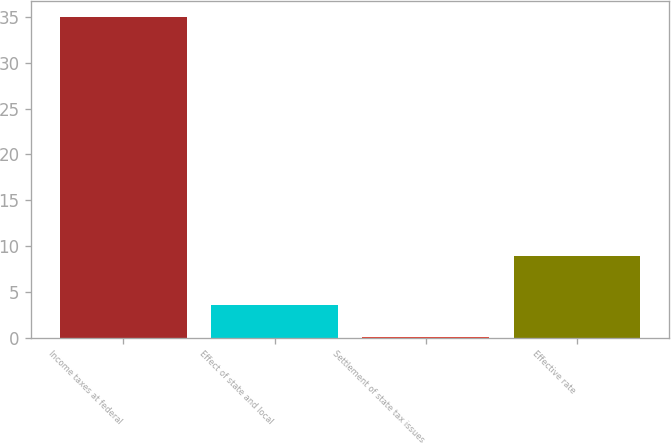<chart> <loc_0><loc_0><loc_500><loc_500><bar_chart><fcel>Income taxes at federal<fcel>Effect of state and local<fcel>Settlement of state tax issues<fcel>Effective rate<nl><fcel>35<fcel>3.59<fcel>0.1<fcel>8.9<nl></chart> 